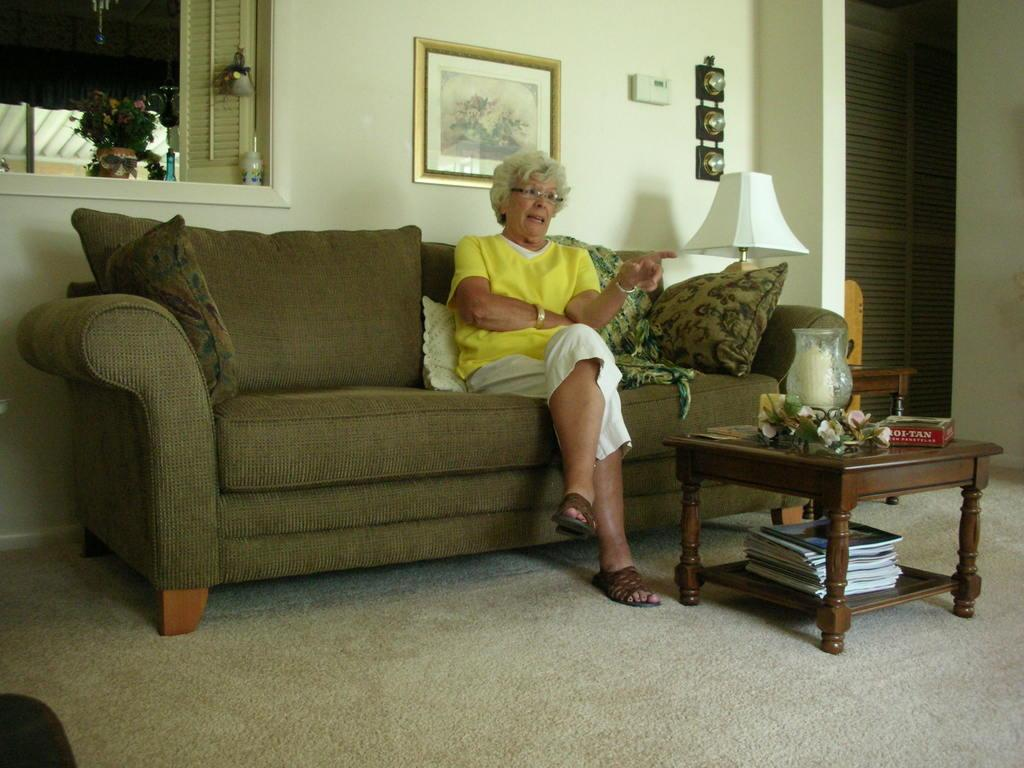What is the woman in the image doing? The woman is sitting on a sofa. What is located behind the woman? There is a table behind the woman. What objects can be seen on the table? The table has a flower vase and a lamp on it. What is located beside the woman? There is a photo frame beside the woman. What type of rub is the woman applying to her skin in the image? There is no indication in the image that the woman is applying any rub to her skin. 